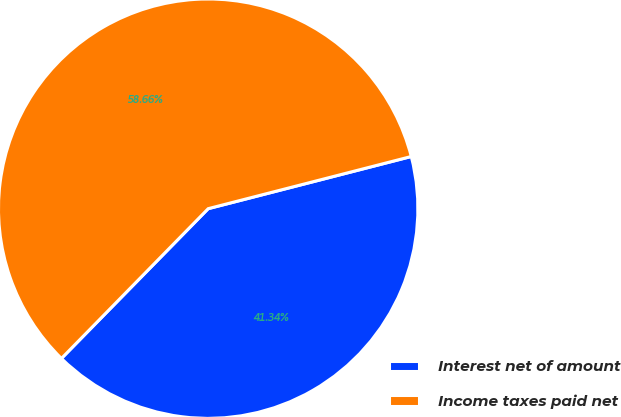Convert chart. <chart><loc_0><loc_0><loc_500><loc_500><pie_chart><fcel>Interest net of amount<fcel>Income taxes paid net<nl><fcel>41.34%<fcel>58.66%<nl></chart> 